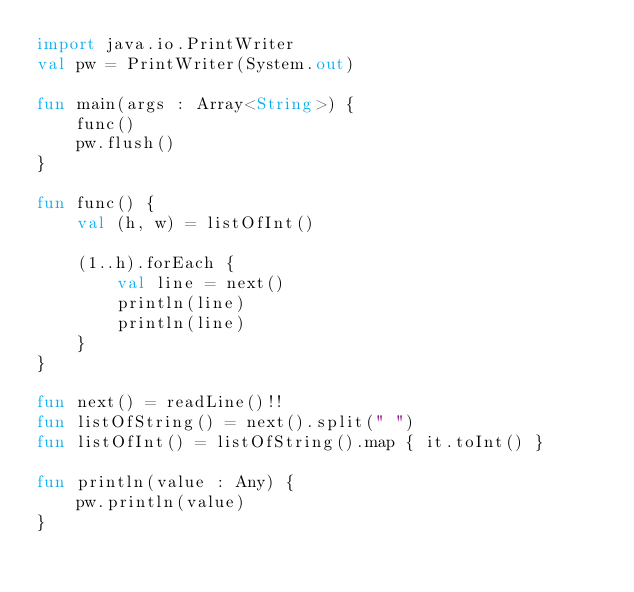<code> <loc_0><loc_0><loc_500><loc_500><_Kotlin_>import java.io.PrintWriter
val pw = PrintWriter(System.out)

fun main(args : Array<String>) {
    func()
    pw.flush()
}

fun func() {
    val (h, w) = listOfInt()

    (1..h).forEach {
        val line = next()
        println(line)
        println(line)
    }
}

fun next() = readLine()!!
fun listOfString() = next().split(" ")
fun listOfInt() = listOfString().map { it.toInt() }

fun println(value : Any) {
    pw.println(value)
}</code> 